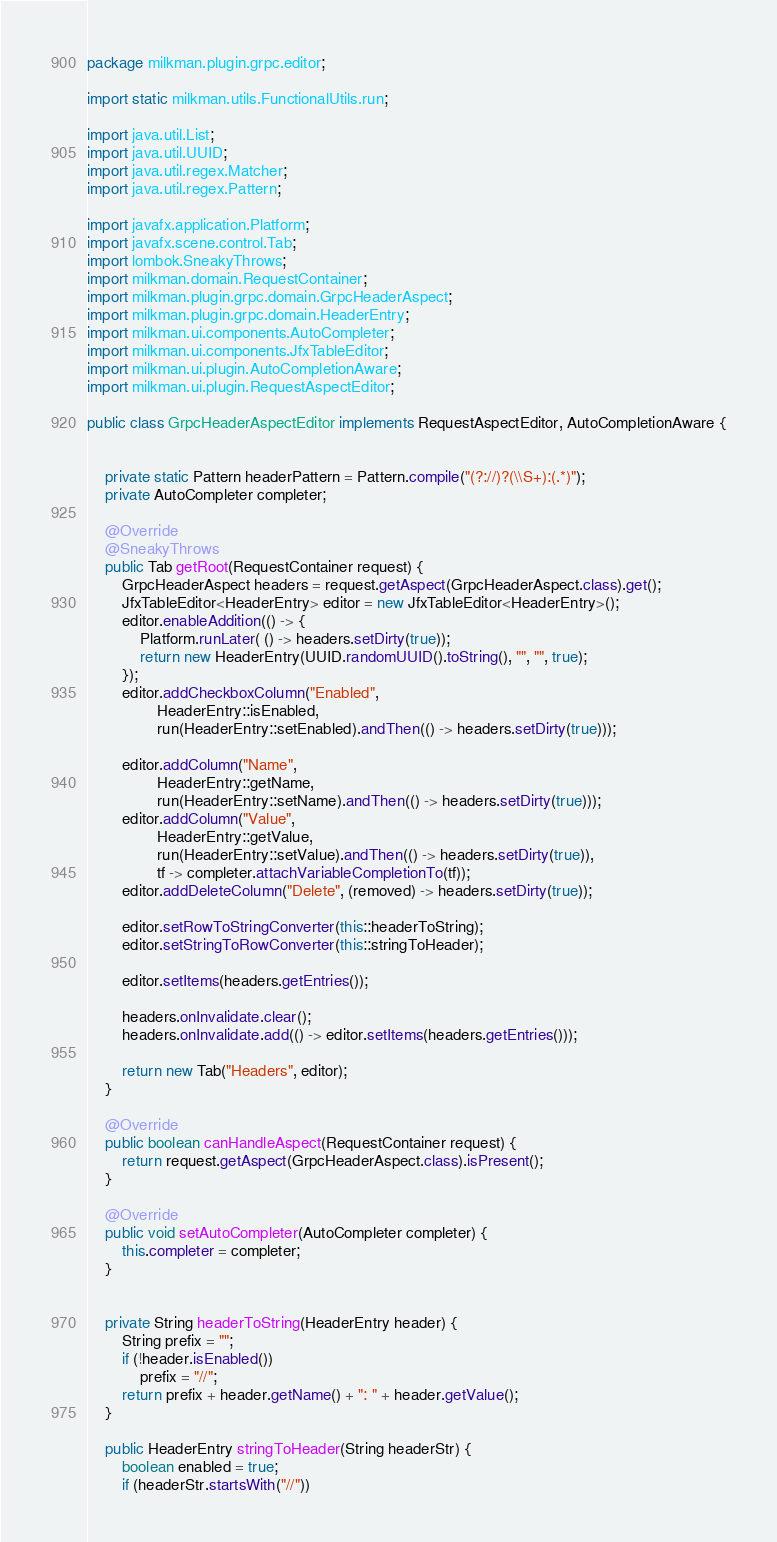<code> <loc_0><loc_0><loc_500><loc_500><_Java_>package milkman.plugin.grpc.editor;

import static milkman.utils.FunctionalUtils.run;

import java.util.List;
import java.util.UUID;
import java.util.regex.Matcher;
import java.util.regex.Pattern;

import javafx.application.Platform;
import javafx.scene.control.Tab;
import lombok.SneakyThrows;
import milkman.domain.RequestContainer;
import milkman.plugin.grpc.domain.GrpcHeaderAspect;
import milkman.plugin.grpc.domain.HeaderEntry;
import milkman.ui.components.AutoCompleter;
import milkman.ui.components.JfxTableEditor;
import milkman.ui.plugin.AutoCompletionAware;
import milkman.ui.plugin.RequestAspectEditor;

public class GrpcHeaderAspectEditor implements RequestAspectEditor, AutoCompletionAware {


	private static Pattern headerPattern = Pattern.compile("(?://)?(\\S+):(.*)");
	private AutoCompleter completer;
	
	@Override
	@SneakyThrows
	public Tab getRoot(RequestContainer request) {
		GrpcHeaderAspect headers = request.getAspect(GrpcHeaderAspect.class).get();
		JfxTableEditor<HeaderEntry> editor = new JfxTableEditor<HeaderEntry>();
		editor.enableAddition(() -> {
			Platform.runLater( () -> headers.setDirty(true));
			return new HeaderEntry(UUID.randomUUID().toString(), "", "", true);
		});
		editor.addCheckboxColumn("Enabled", 
				HeaderEntry::isEnabled, 
				run(HeaderEntry::setEnabled).andThen(() -> headers.setDirty(true)));
		
		editor.addColumn("Name",
				HeaderEntry::getName, 
				run(HeaderEntry::setName).andThen(() -> headers.setDirty(true)));
		editor.addColumn("Value", 
				HeaderEntry::getValue,
				run(HeaderEntry::setValue).andThen(() -> headers.setDirty(true)),
				tf -> completer.attachVariableCompletionTo(tf));
		editor.addDeleteColumn("Delete", (removed) -> headers.setDirty(true));

		editor.setRowToStringConverter(this::headerToString);
		editor.setStringToRowConverter(this::stringToHeader);
		
		editor.setItems(headers.getEntries());
		
		headers.onInvalidate.clear();
		headers.onInvalidate.add(() -> editor.setItems(headers.getEntries()));
		
		return new Tab("Headers", editor);
	}

	@Override
	public boolean canHandleAspect(RequestContainer request) {
		return request.getAspect(GrpcHeaderAspect.class).isPresent();
	}

	@Override
	public void setAutoCompleter(AutoCompleter completer) {
		this.completer = completer;
	}


	private String headerToString(HeaderEntry header) {
		String prefix = "";
		if (!header.isEnabled())
			prefix = "//";
		return prefix + header.getName() + ": " + header.getValue();
	}

	public HeaderEntry stringToHeader(String headerStr) {
		boolean enabled = true;
		if (headerStr.startsWith("//"))</code> 